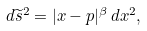<formula> <loc_0><loc_0><loc_500><loc_500>d \widetilde { s } ^ { 2 } = | x - p | ^ { \beta } \, d x ^ { 2 } ,</formula> 